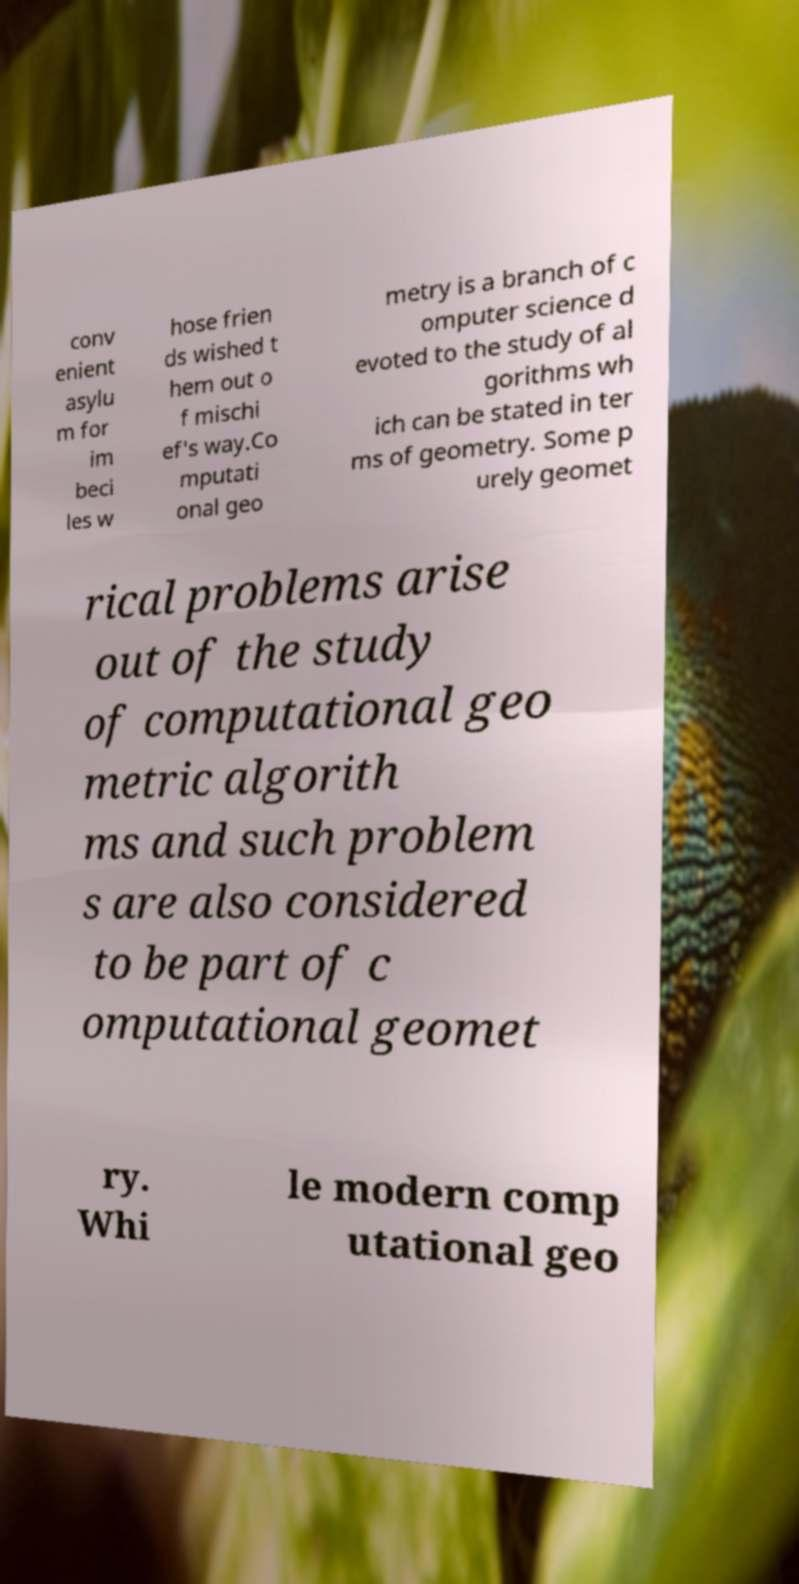Could you assist in decoding the text presented in this image and type it out clearly? conv enient asylu m for im beci les w hose frien ds wished t hem out o f mischi ef's way.Co mputati onal geo metry is a branch of c omputer science d evoted to the study of al gorithms wh ich can be stated in ter ms of geometry. Some p urely geomet rical problems arise out of the study of computational geo metric algorith ms and such problem s are also considered to be part of c omputational geomet ry. Whi le modern comp utational geo 